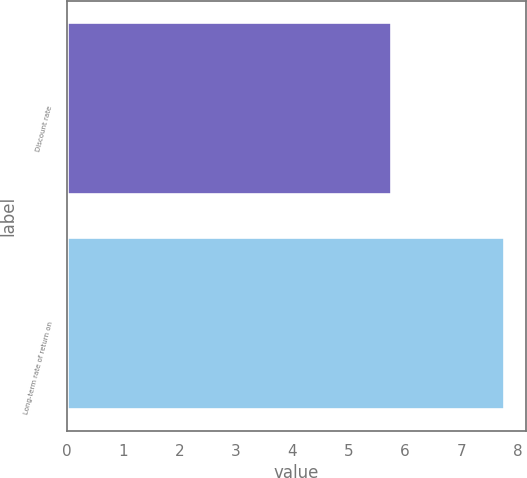Convert chart to OTSL. <chart><loc_0><loc_0><loc_500><loc_500><bar_chart><fcel>Discount rate<fcel>Long-term rate of return on<nl><fcel>5.75<fcel>7.75<nl></chart> 